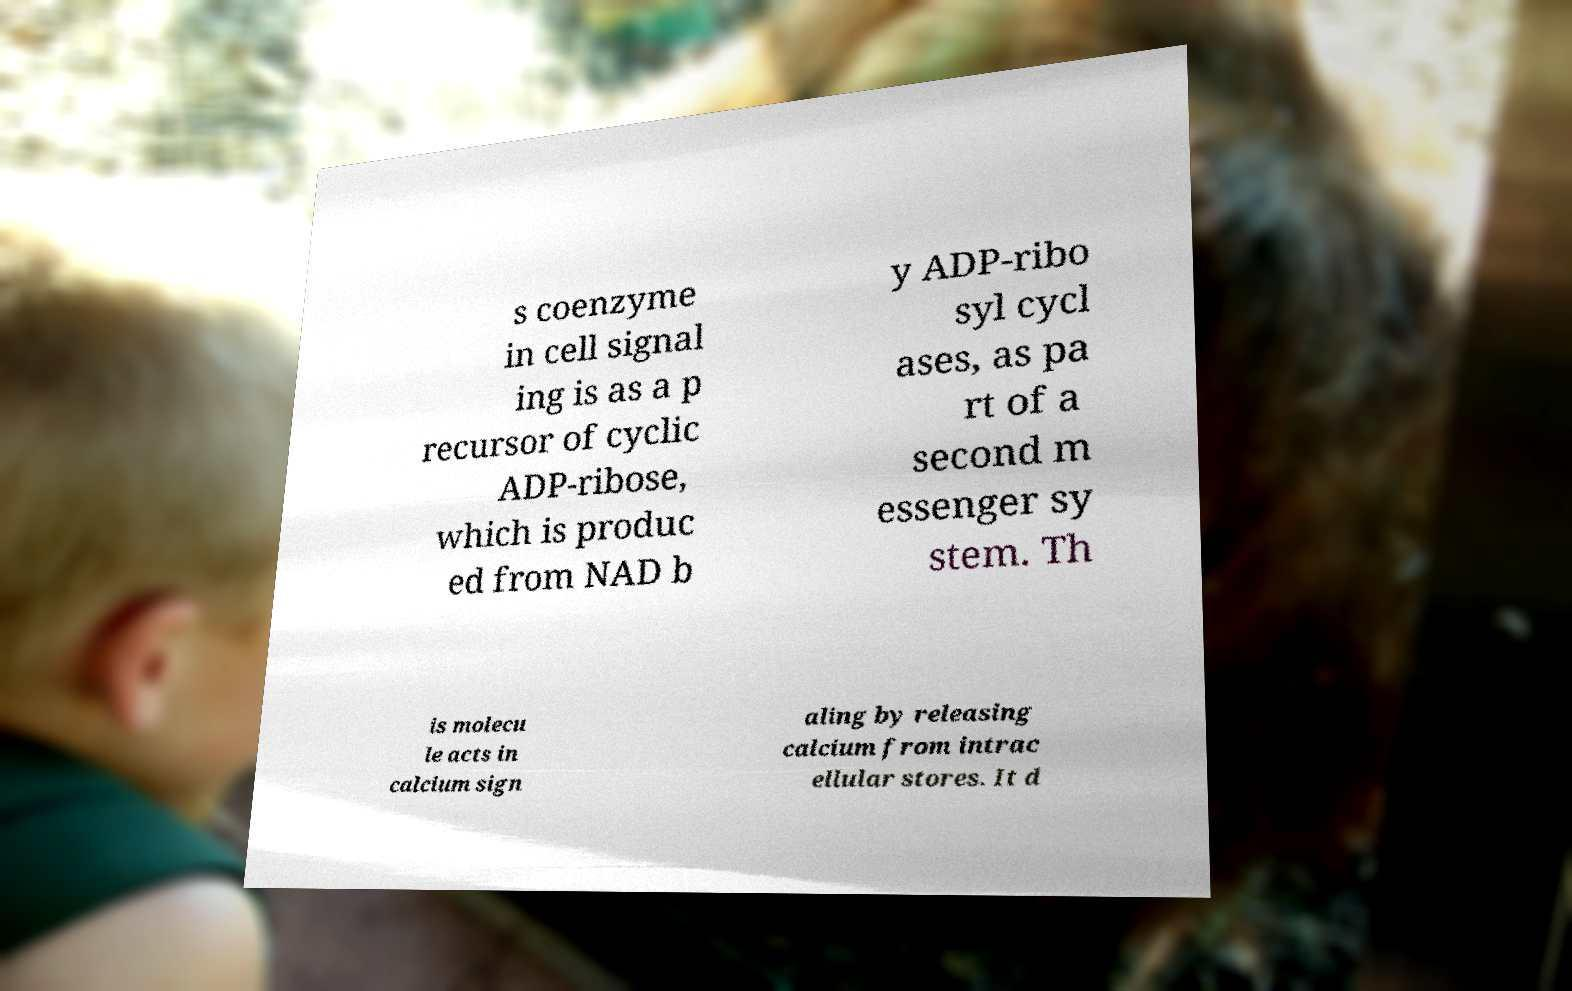What messages or text are displayed in this image? I need them in a readable, typed format. s coenzyme in cell signal ing is as a p recursor of cyclic ADP-ribose, which is produc ed from NAD b y ADP-ribo syl cycl ases, as pa rt of a second m essenger sy stem. Th is molecu le acts in calcium sign aling by releasing calcium from intrac ellular stores. It d 